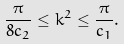Convert formula to latex. <formula><loc_0><loc_0><loc_500><loc_500>\frac { \pi } { 8 c _ { 2 } } \leq k ^ { 2 } \leq \frac { \pi } { c _ { 1 } } .</formula> 